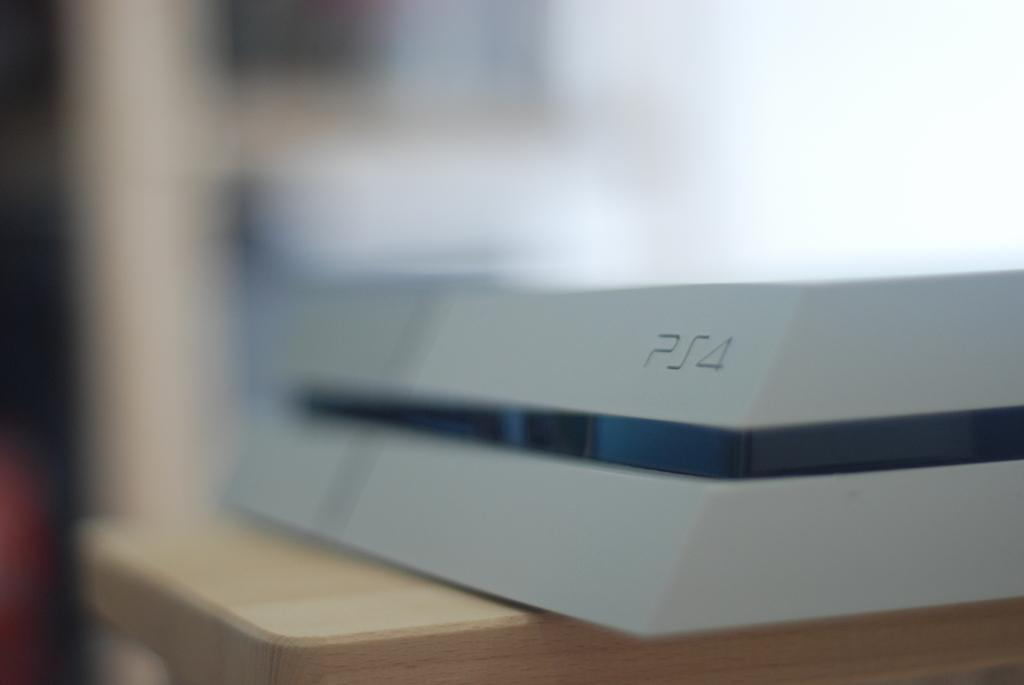<image>
Summarize the visual content of the image. A grey gaming console with PS4 written on it. 